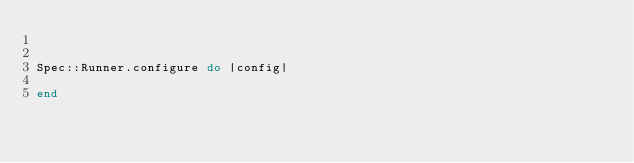Convert code to text. <code><loc_0><loc_0><loc_500><loc_500><_Ruby_>

Spec::Runner.configure do |config|
  
end
</code> 